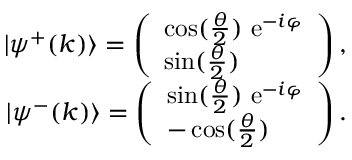Convert formula to latex. <formula><loc_0><loc_0><loc_500><loc_500>\begin{array} { r l r } & { | \psi ^ { + } ( k ) \rangle = \left ( \begin{array} { l } { \cos ( \frac { \theta } { 2 } ) e ^ { - i \varphi } } \\ { \sin ( \frac { \theta } { 2 } ) } \end{array} \right ) , } \\ & { | \psi ^ { - } ( k ) \rangle = \left ( \begin{array} { l } { \sin ( \frac { \theta } { 2 } ) e ^ { - i \varphi } } \\ { - \cos ( \frac { \theta } { 2 } ) } \end{array} \right ) . } \end{array}</formula> 